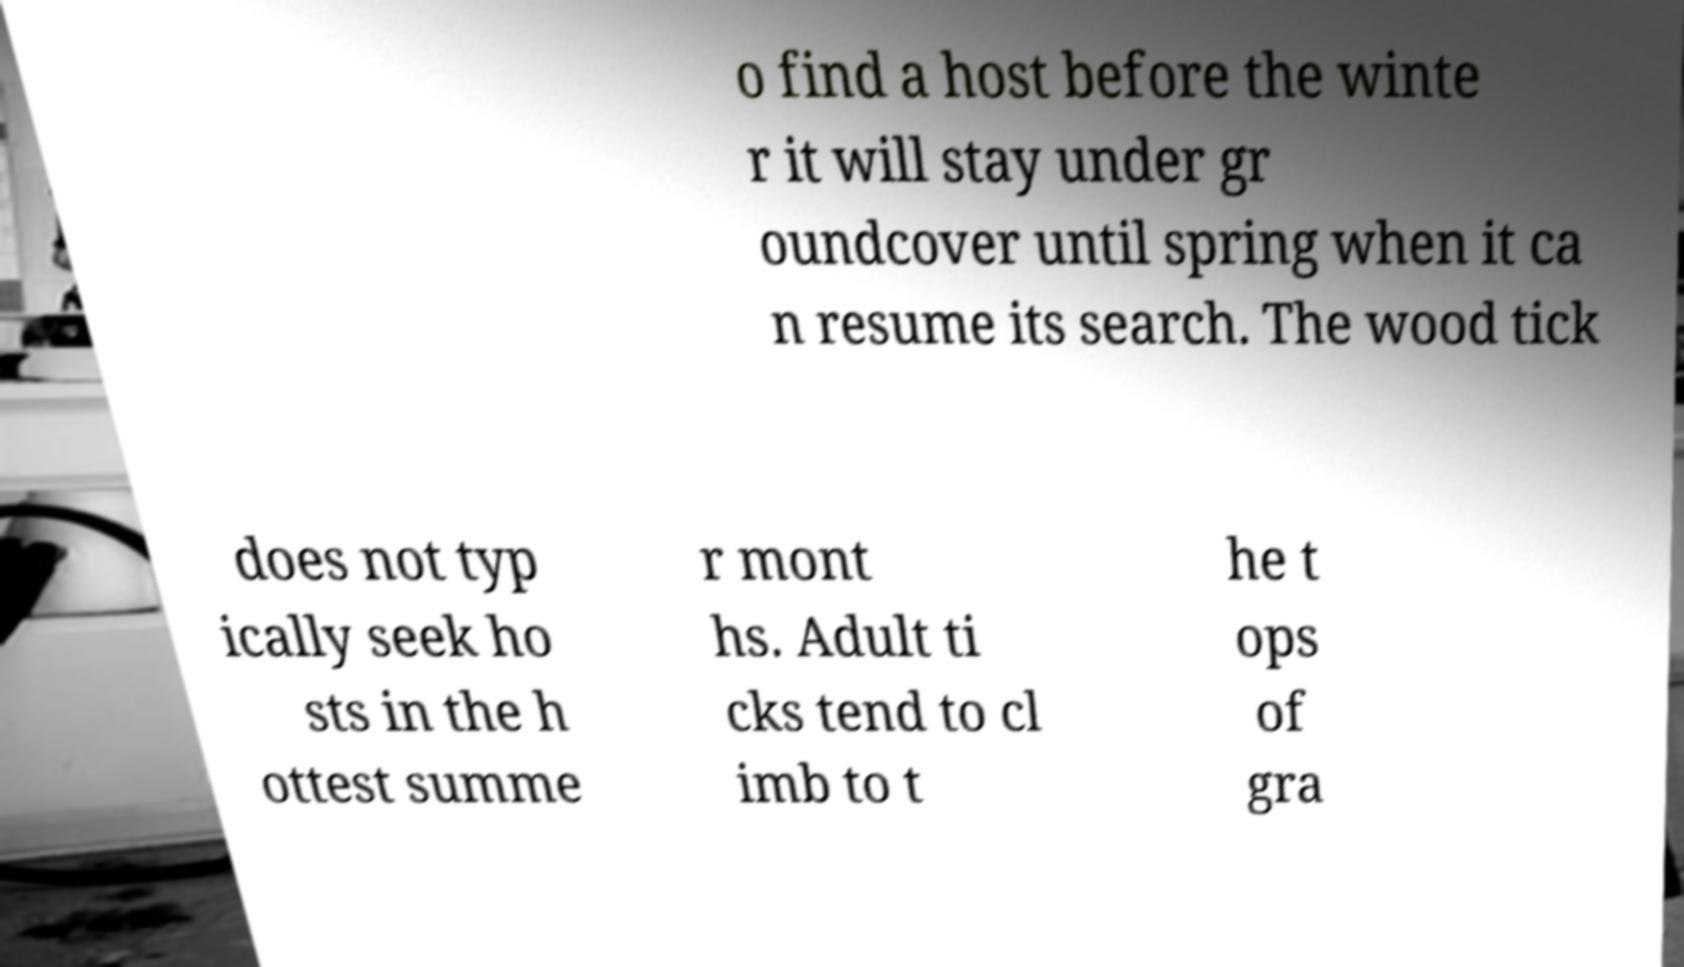Can you accurately transcribe the text from the provided image for me? o find a host before the winte r it will stay under gr oundcover until spring when it ca n resume its search. The wood tick does not typ ically seek ho sts in the h ottest summe r mont hs. Adult ti cks tend to cl imb to t he t ops of gra 